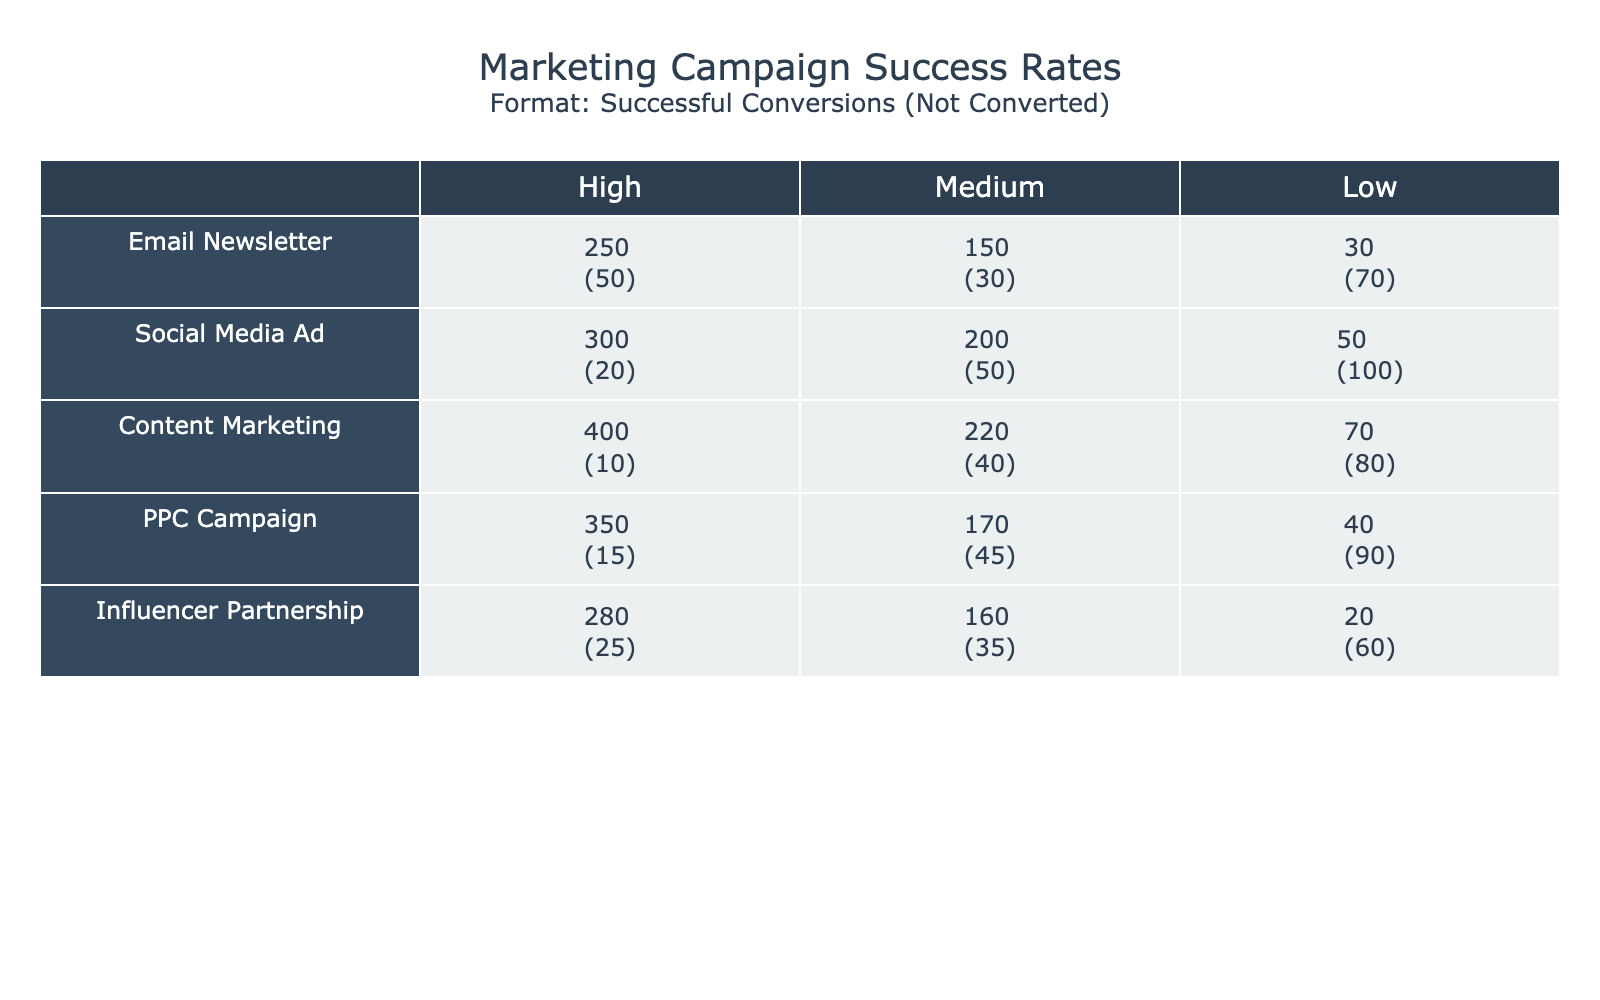What is the total number of successful conversions from the Content Marketing campaign? From the table, we can find that the successful conversions for Content Marketing at High, Medium, and Low engagement levels are 400, 220, and 70 respectively. Adding these together gives us 400 + 220 + 70 = 690.
Answer: 690 Which campaign had the highest successful conversions at Low user engagement? Upon examining the table, the successful conversions for campaigns at Low user engagement are as follows: Email Newsletter (30), Social Media Ad (50), Content Marketing (70), PPC Campaign (40), and Influencer Partnership (20). The highest among these is 70 from Content Marketing.
Answer: Content Marketing Is it true that the Social Media Ad campaign had more not converted users than the Email Newsletter campaign at Medium engagement? For Social Media Ad at Medium engagement, there are 50 not converted users. For Email Newsletter at Medium engagement, there are 30 not converted users. Since 50 is greater than 30, the statement is true.
Answer: Yes What is the overall total number of not converted users across all campaigns at High user engagement? We can gather the not converted numbers at High engagement: Email Newsletter (50), Social Media Ad (20), Content Marketing (10), PPC Campaign (15), and Influencer Partnership (25). Summing these values gives 50 + 20 + 10 + 15 + 25 = 120.
Answer: 120 Which campaign had the lowest successful conversion rate when comparing High and Low user engagement levels? To find the conversion rate, we need to calculate the successful conversion divided by the total attempts for both High and Low engagement levels. The total for each campaign at High and Low engagement is: Email Newsletter (250 + 50 = 300), Social Media Ad (300 + 20 = 320), Content Marketing (400 + 10 = 410), PPC Campaign (350 + 15 = 365), and Influencer Partnership (280 + 25 = 305). The rates are Email Newsletter (250/300), Social Media Ad (300/320), Content Marketing (400/410), PPC Campaign (350/365), and Influencer Partnership (280/305). Calculating the rates gives us: Email Newsletter ~ 0.833, Social Media Ad ~ 0.938, Content Marketing ~ 0.975, PPC Campaign ~ 0.958, and Influencer Partnership ~ 0.918. Thus, Email Newsletter had the lowest rate of approximately 0.833.
Answer: Email Newsletter 